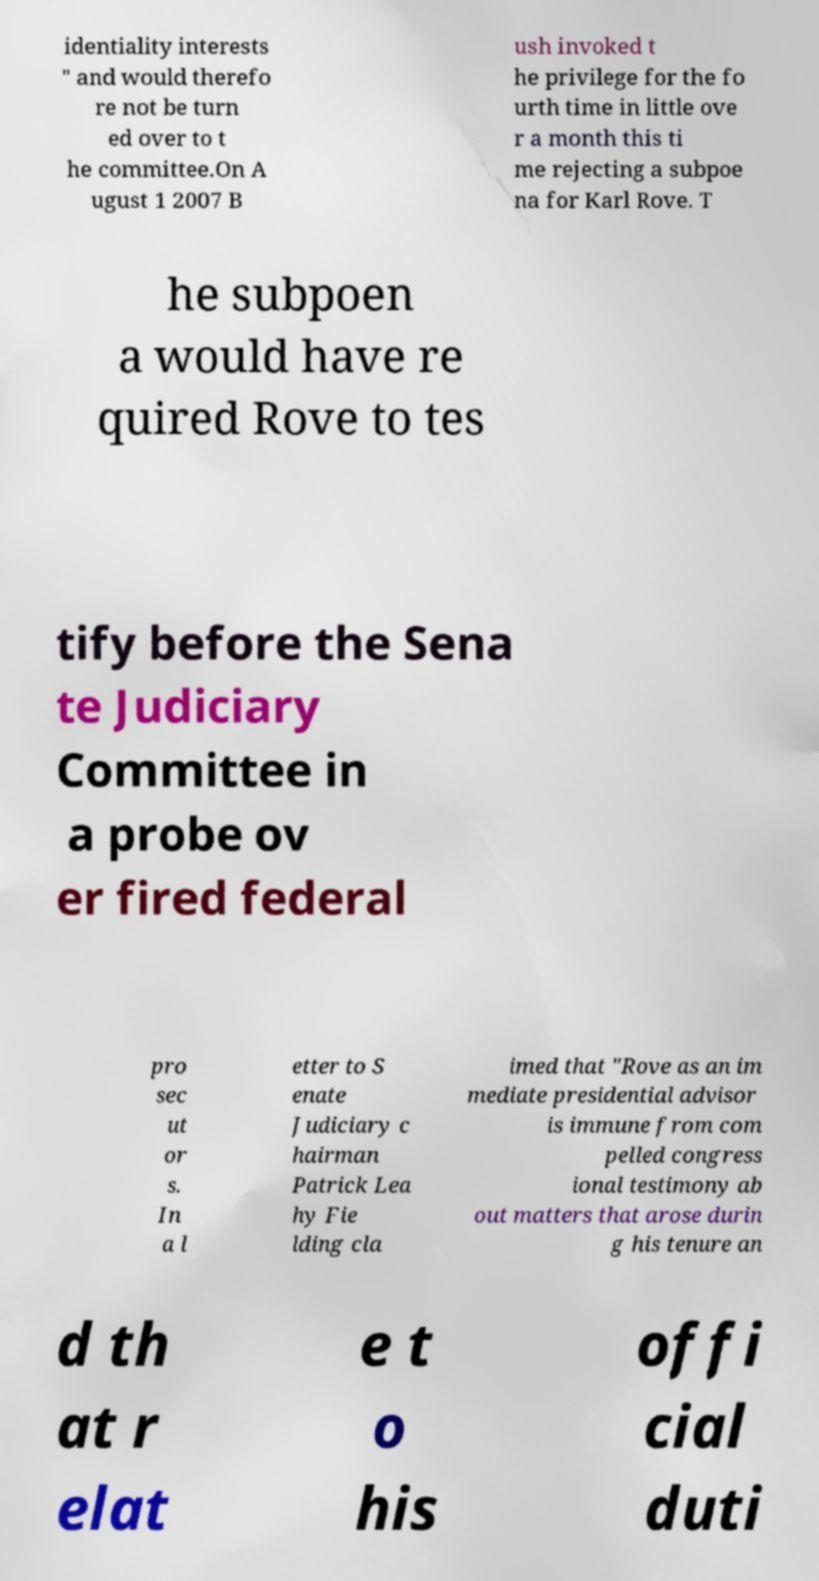Please identify and transcribe the text found in this image. identiality interests " and would therefo re not be turn ed over to t he committee.On A ugust 1 2007 B ush invoked t he privilege for the fo urth time in little ove r a month this ti me rejecting a subpoe na for Karl Rove. T he subpoen a would have re quired Rove to tes tify before the Sena te Judiciary Committee in a probe ov er fired federal pro sec ut or s. In a l etter to S enate Judiciary c hairman Patrick Lea hy Fie lding cla imed that "Rove as an im mediate presidential advisor is immune from com pelled congress ional testimony ab out matters that arose durin g his tenure an d th at r elat e t o his offi cial duti 